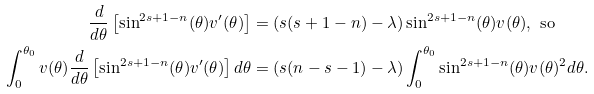Convert formula to latex. <formula><loc_0><loc_0><loc_500><loc_500>\frac { d } { d \theta } \left [ \sin ^ { 2 s + 1 - n } ( \theta ) v ^ { \prime } ( \theta ) \right ] & = ( s ( s + 1 - n ) - \lambda ) \sin ^ { 2 s + 1 - n } ( \theta ) v ( \theta ) , \text { so} \\ \int _ { 0 } ^ { \theta _ { 0 } } v ( \theta ) \frac { d } { d \theta } \left [ \sin ^ { 2 s + 1 - n } ( \theta ) v ^ { \prime } ( \theta ) \right ] d \theta & = ( s ( n - s - 1 ) - \lambda ) \int _ { 0 } ^ { \theta _ { 0 } } \sin ^ { 2 s + 1 - n } ( \theta ) v ( \theta ) ^ { 2 } d \theta .</formula> 